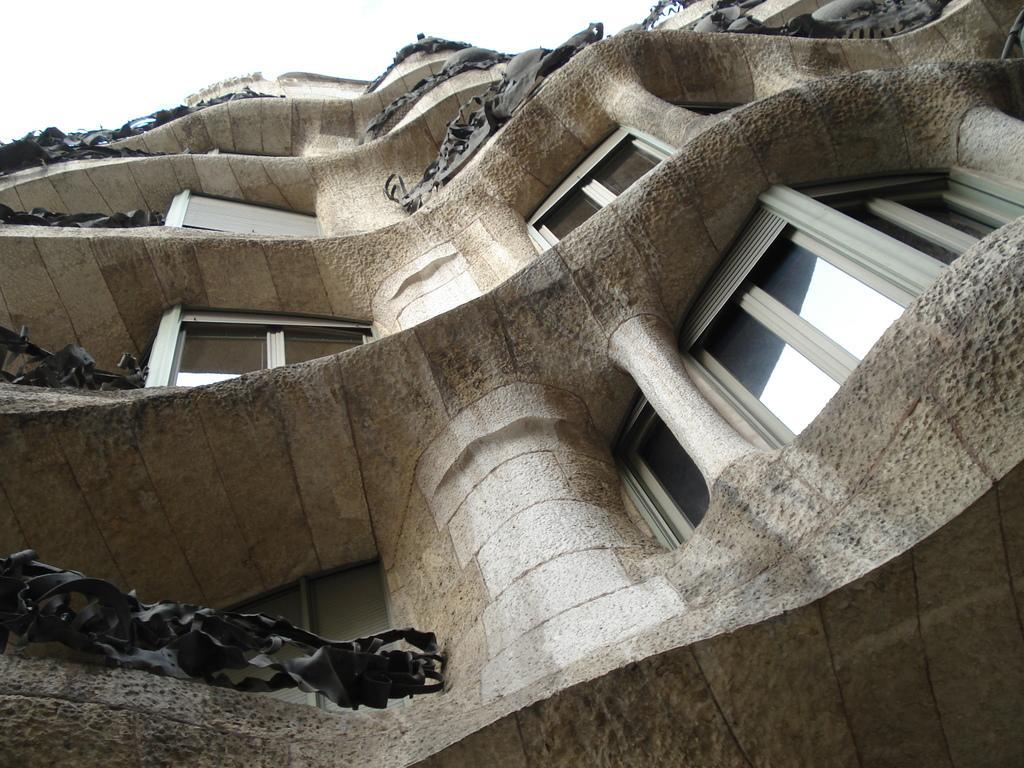How would you summarize this image in a sentence or two? Here we can see a building, windows, and glasses. In the background there is sky. 